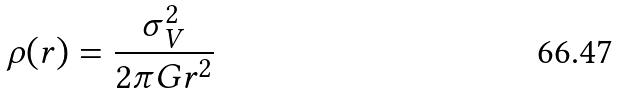<formula> <loc_0><loc_0><loc_500><loc_500>\rho ( r ) = \frac { \sigma _ { V } ^ { 2 } } { 2 \pi G r ^ { 2 } }</formula> 